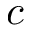<formula> <loc_0><loc_0><loc_500><loc_500>c</formula> 